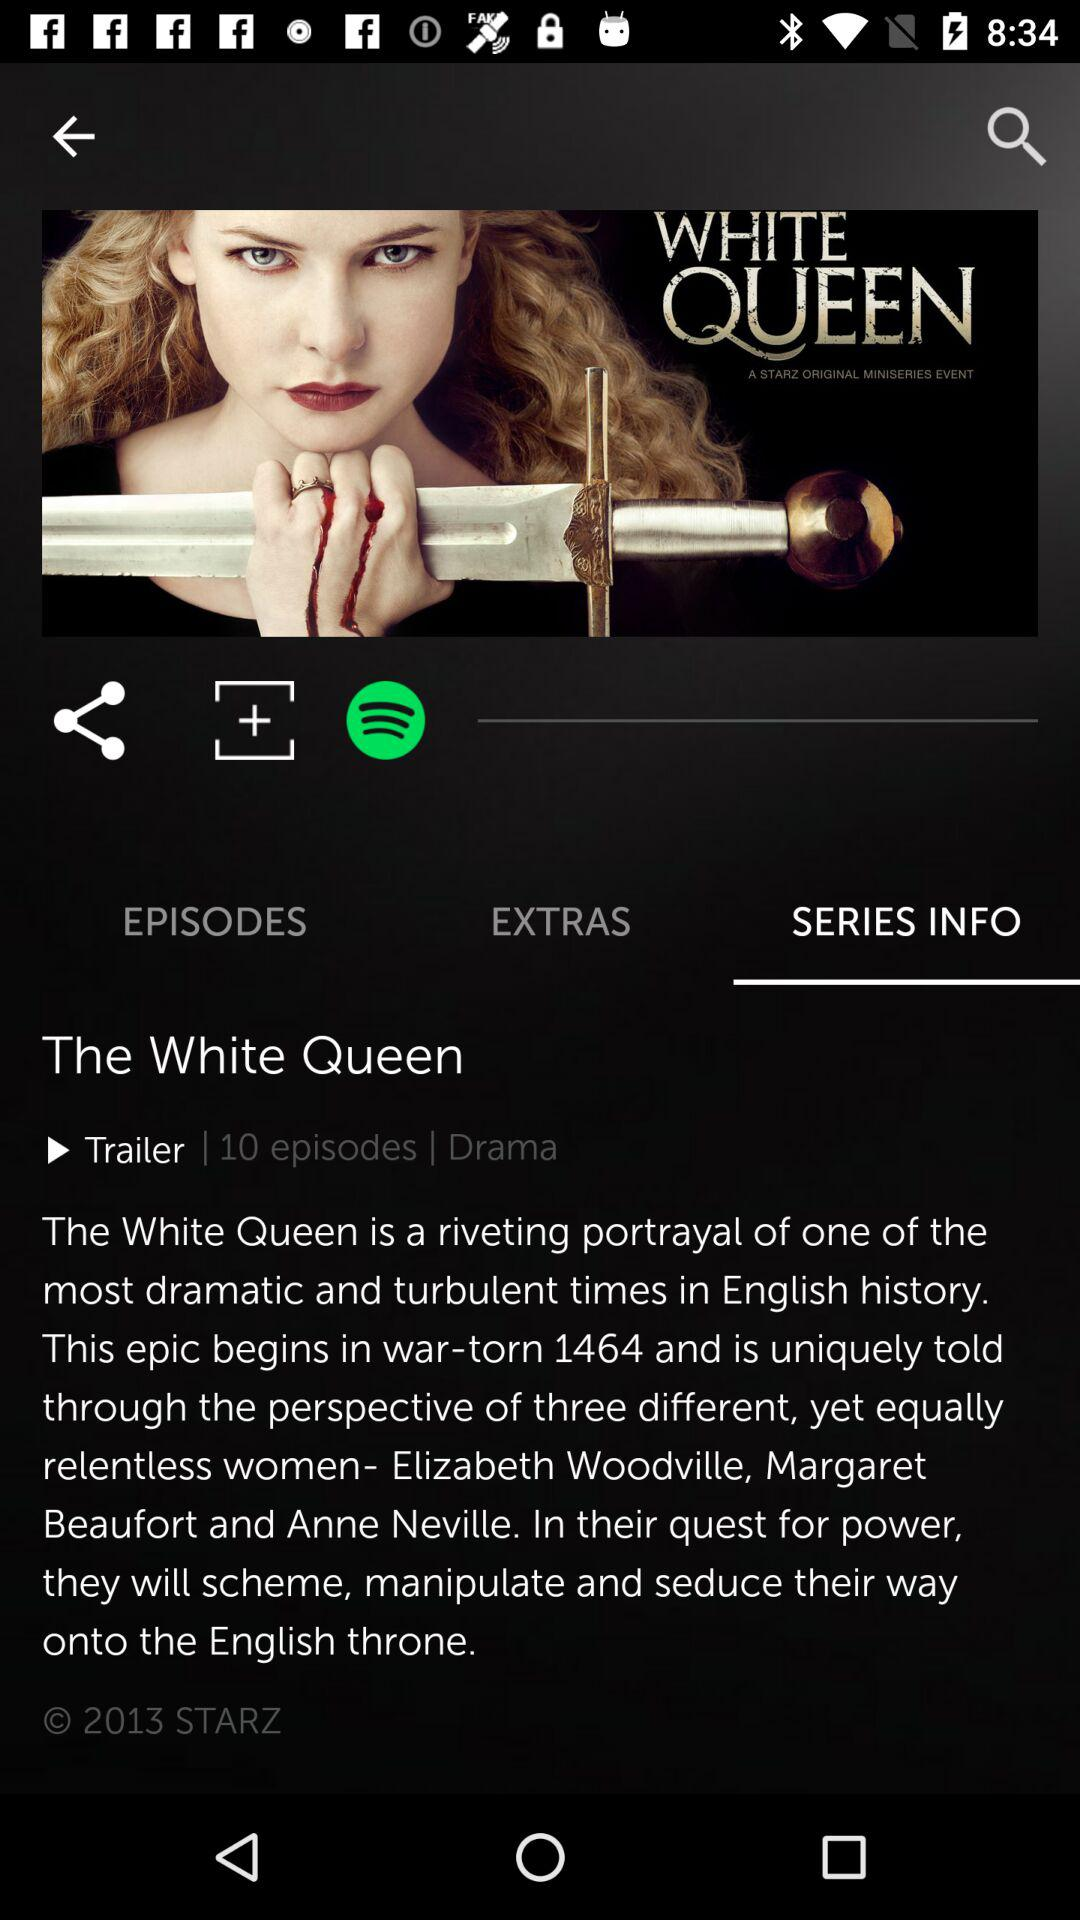Which tab has been selected? The tab that has been selected is "SERIES INFO". 